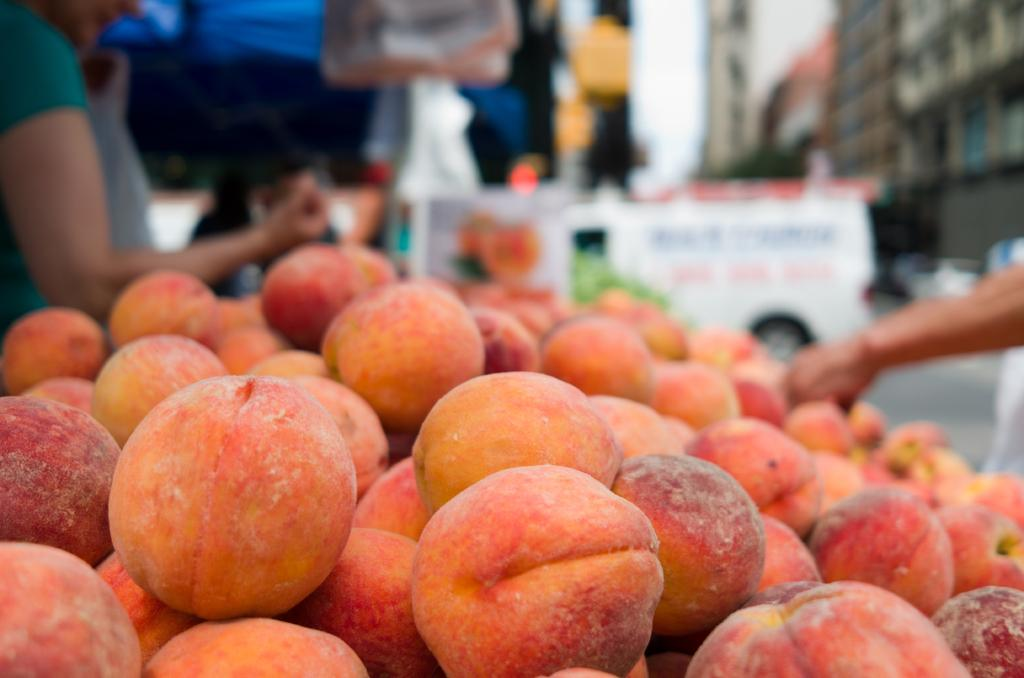What type of food items can be seen in the image? There are fruits in the image. What else is visible in the background of the image? There are people in the background of the image. What mode of transportation can be seen in the image? There is a truck on the road in the image. What type of structure is present in the image? There is a building in the image. What color is the shirt worn by the person at the meeting in the image? There is no meeting or person wearing a shirt in the image. 